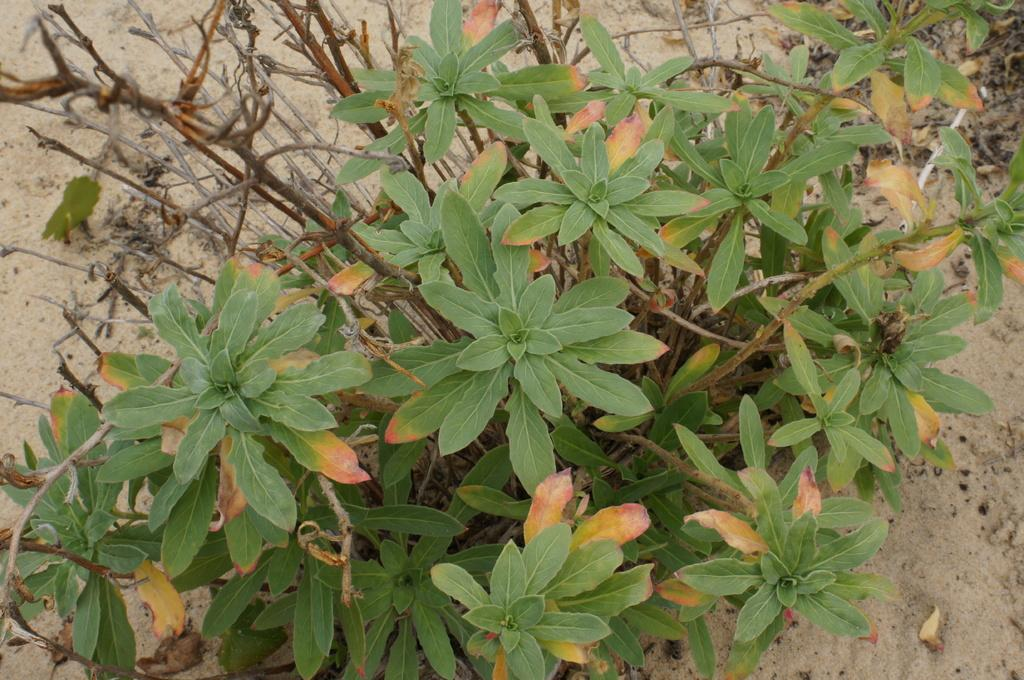What type of vegetation is present in the image? There are plants with stems and leaves in the image. What can be seen in the background of the image? There is sand visible in the background of the image. What type of eggnog is being served at the father's roadside stand in the image? There is no mention of eggnog, a father, or a roadside stand in the image. The image only features plants with stems and leaves, and sand in the background. 